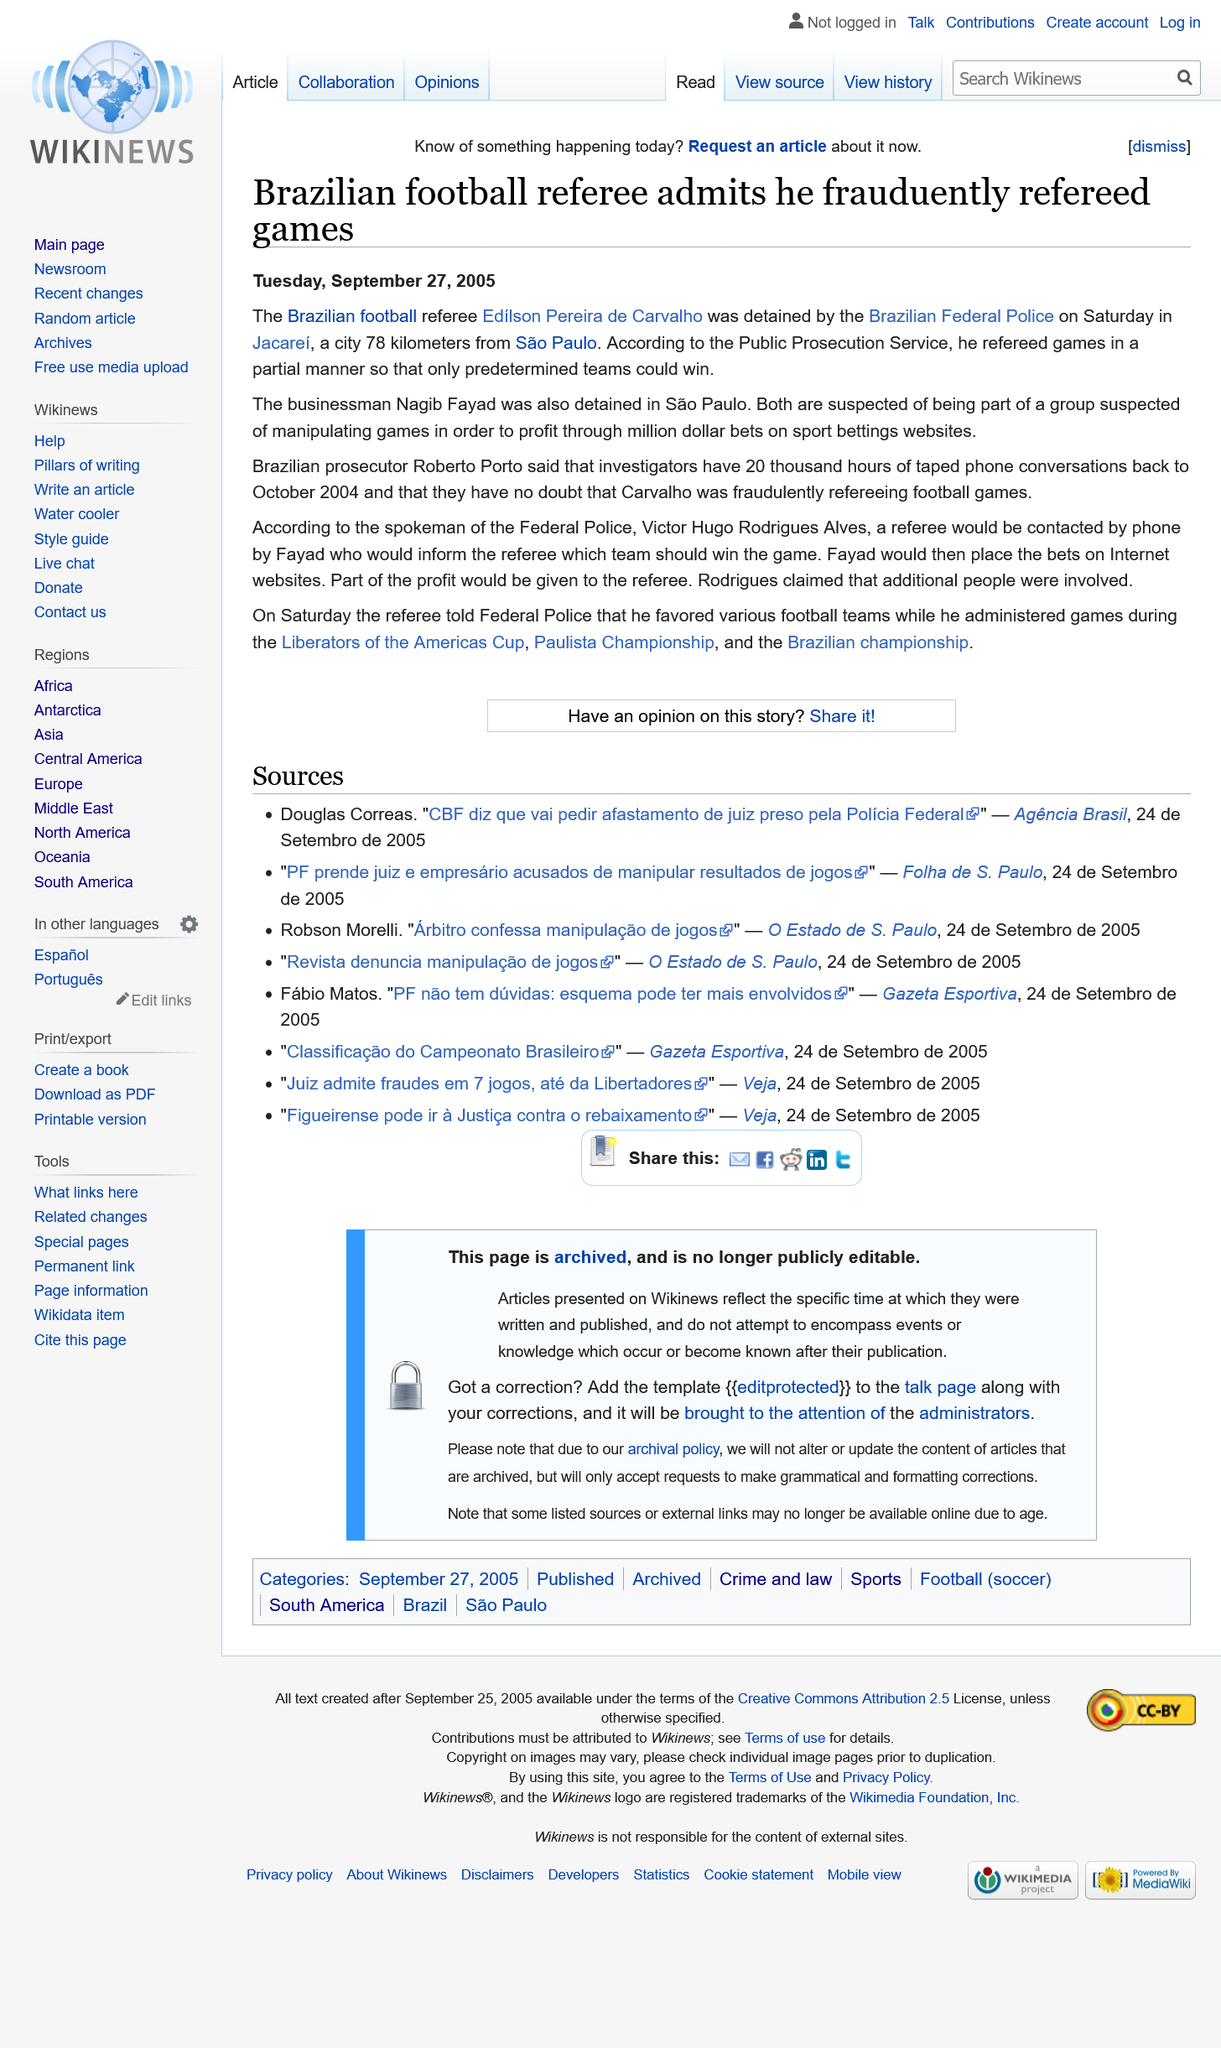Outline some significant characteristics in this image. A total of two individuals, Nagib Fayad and Edilson Pereira de Carvalho, were detained in connection to this matter. The article was written on Tuesday 27th September 2005. Edilson Pereira de Carvalho is being accused of fraudulently refereeing football games in Brazil. 